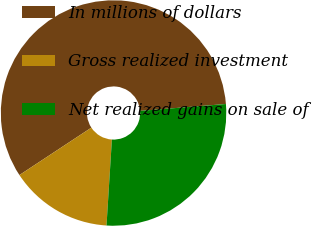Convert chart. <chart><loc_0><loc_0><loc_500><loc_500><pie_chart><fcel>In millions of dollars<fcel>Gross realized investment<fcel>Net realized gains on sale of<nl><fcel>58.0%<fcel>14.73%<fcel>27.27%<nl></chart> 